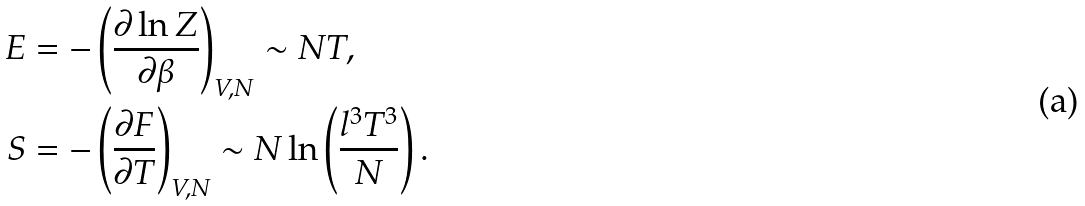<formula> <loc_0><loc_0><loc_500><loc_500>E & = - \left ( \frac { \partial \ln Z } { \partial \beta } \right ) _ { V , N } \sim N T , \\ S & = - \left ( \frac { \partial F } { \partial T } \right ) _ { V , N } \sim N \ln \left ( \frac { l ^ { 3 } T ^ { 3 } } { N } \right ) .</formula> 